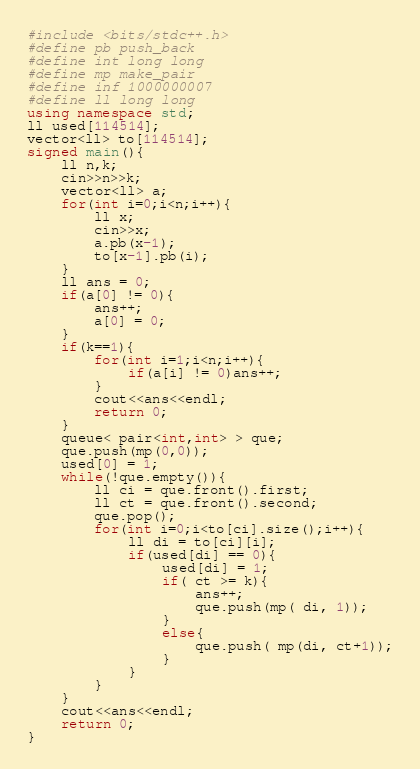Convert code to text. <code><loc_0><loc_0><loc_500><loc_500><_C++_>#include <bits/stdc++.h>
#define pb push_back
#define int long long
#define mp make_pair
#define inf 1000000007
#define ll long long
using namespace std;
ll used[114514];
vector<ll> to[114514];
signed main(){
	ll n,k;
	cin>>n>>k;
	vector<ll> a;
	for(int i=0;i<n;i++){
		ll x;
		cin>>x;
		a.pb(x-1);
		to[x-1].pb(i);
	}
	ll ans = 0;
	if(a[0] != 0){
		ans++;
		a[0] = 0;
	}
	if(k==1){
		for(int i=1;i<n;i++){
			if(a[i] != 0)ans++;
		}
		cout<<ans<<endl;
		return 0;
	}
	queue< pair<int,int> > que;
	que.push(mp(0,0));
	used[0] = 1;
	while(!que.empty()){
		ll ci = que.front().first;
		ll ct = que.front().second;
		que.pop();
		for(int i=0;i<to[ci].size();i++){
			ll di = to[ci][i];
			if(used[di] == 0){
				used[di] = 1;
				if( ct >= k){
					ans++;
					que.push(mp( di, 1));
				}
				else{
					que.push( mp(di, ct+1));
				}
			}
		}
	}
	cout<<ans<<endl;
	return 0;
}</code> 